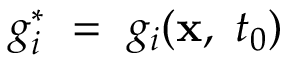Convert formula to latex. <formula><loc_0><loc_0><loc_500><loc_500>g _ { i } ^ { * } = g _ { i } ( x , \ t _ { 0 } )</formula> 